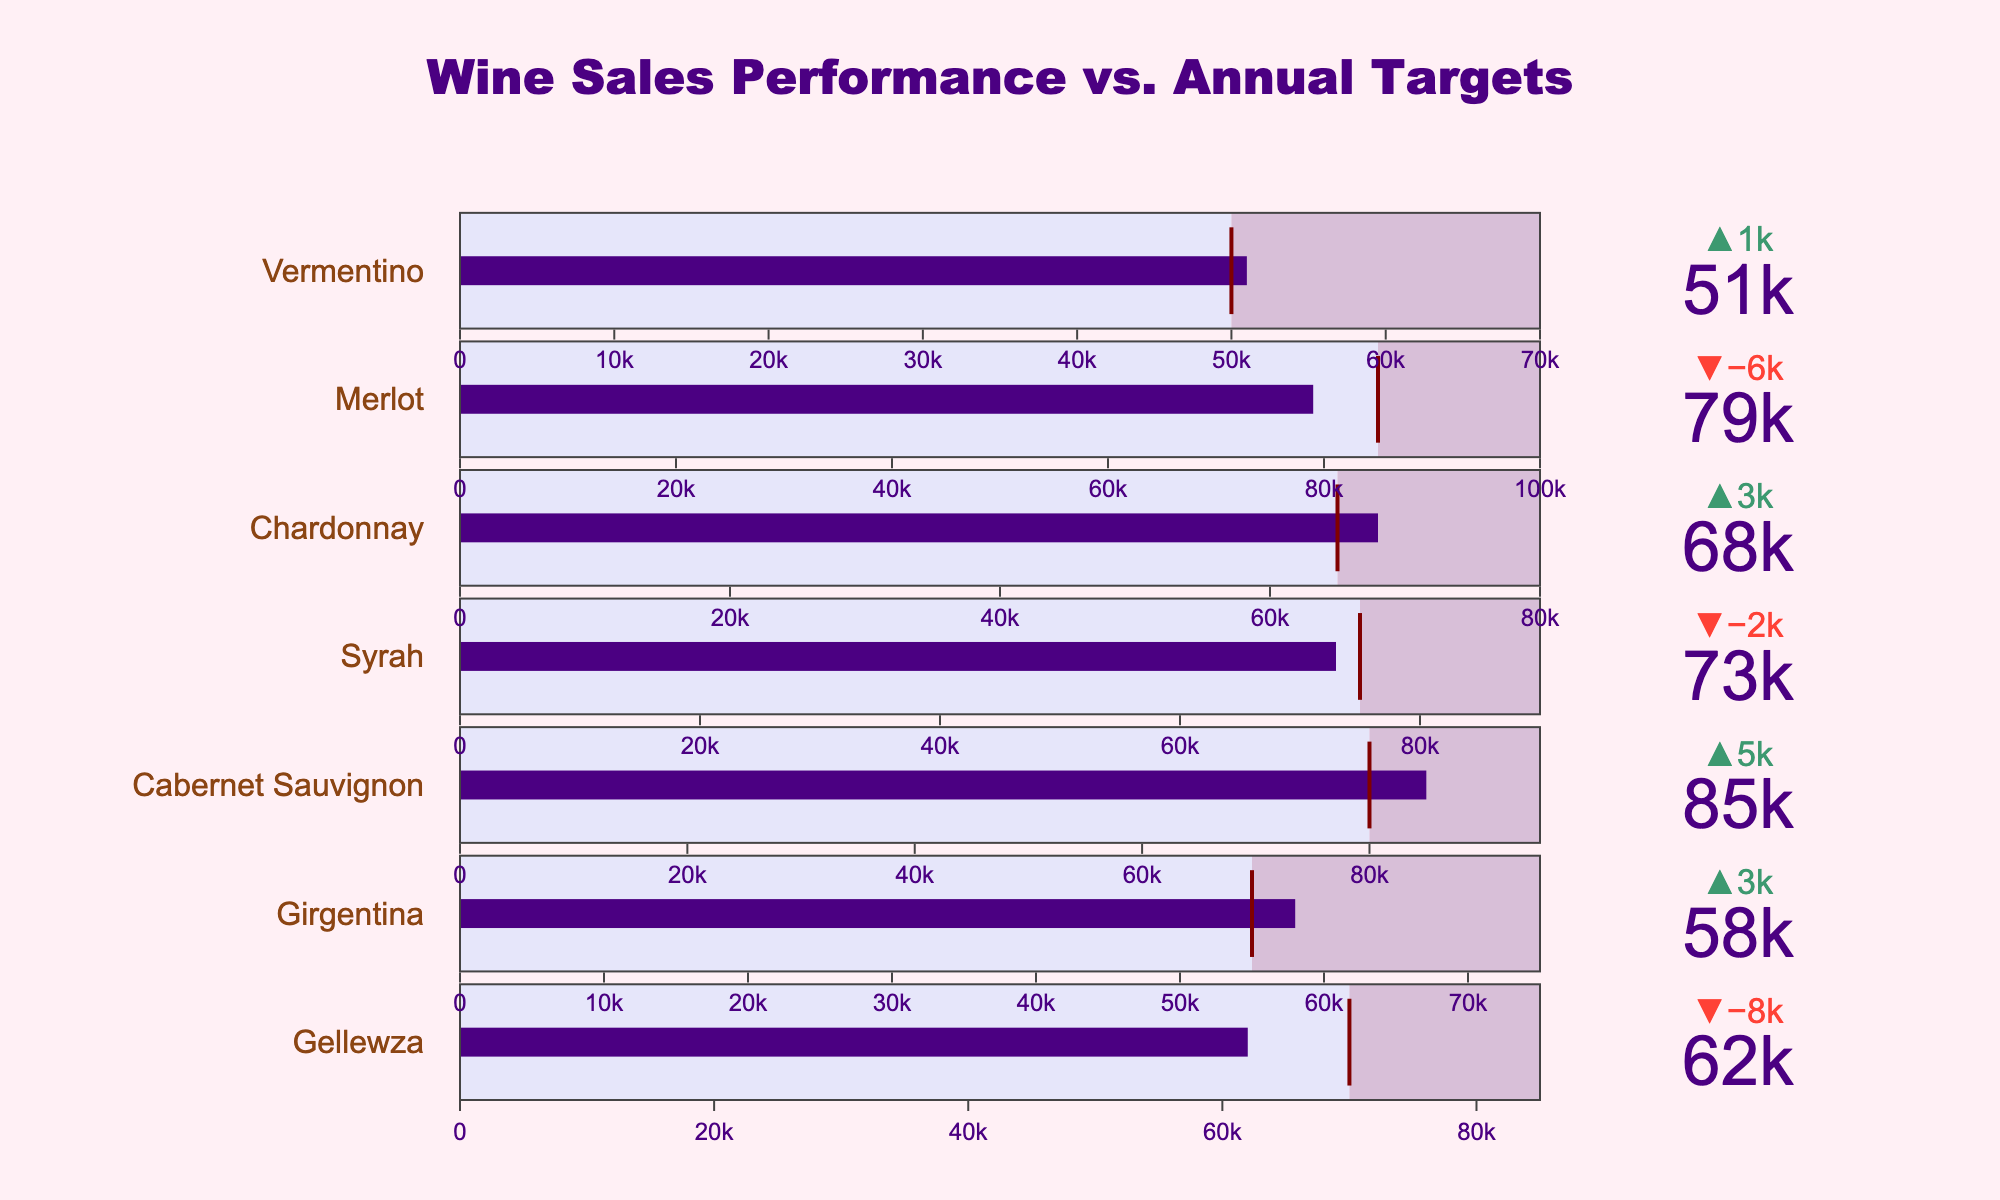What is the title of the chart? Look at the top of the chart where the title is usually placed. The title is "Wine Sales Performance vs. Annual Targets"
Answer: Wine Sales Performance vs. Annual Targets Which grape variety had the highest actual sales? Checking each bullet chart, "Cabernet Sauvignon" has the highest value for actual sales, at 85,000.
Answer: Cabernet Sauvignon Did Gellewza meet its target sales? The delta indicator shows '62000' against a target of '70000', with a clear gap between the actual sales bar and the target line.
Answer: No How much higher are the actual sales of Merlot compared to its target sales? The actual sales for Merlot are 79,000 and its target sales are 85,000. The amount it fell short is calculated as 85,000 - 79,000 = 6,000.
Answer: 6,000 Which grape variety exceeded its target sales by the largest margin? We see that "Vermentino" has actual sales of 51,000 against a target of 50,000, exceeding its target only by a smaller margin compared to "Girgentina" with actual sales of 58,000 against a target of 55,000. So, "Girgentina" exceeded its target by 3,000.
Answer: Girgentina Which grape variety fell shortest of its maximum sales potential? Checking the maximum sales bars, "Merlot" has target sales of 85,000 and maximum sales of 100,000. It fell short of its potential by 100,000 - 79,000 = 21,000, more than any other variety.
Answer: Merlot What can be inferred about the performance of Chardonnay in meeting its target sales? Chardonnay's actual sales are 68,000, and its target is 65,000. Since actual sales exceed the target, Chardonnay met and surpassed its target sales.
Answer: It met and surpassed What is the difference between the actual and target sales of Syrah? Syrah's actual sales are 73,000 compared to the target of 75,000. The difference (shortfall) is calculated as 75,000 - 73,000 = 2,000.
Answer: 2,000 Which grape variety has the nearest sales target to 60,000? Looking at the sales targets, we see that "Girgentina" has a target closest to 60,000, which is noted at 55,000.
Answer: Girgentina How do the actual sales of Vermentino compare to its maximum sales potential? Vermentino’s actual sales are 51,000 and its maximum potential is 70,000. The difference is 70,000 - 51,000 = 19,000.
Answer: 19,000 